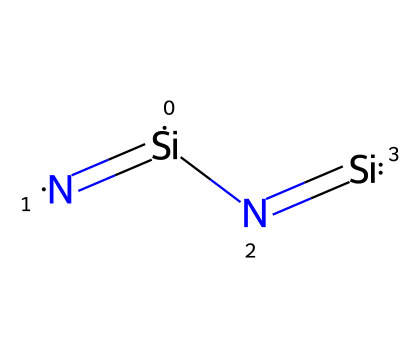What is the primary element in this chemical? The chemical structure predominantly features silicon, indicated by the presence of the Si atoms.
Answer: silicon How many nitrogen atoms are present in this chemical? The SMILES representation shows two nitrogen atoms connected to silicon, indicated by the [N] symbols.
Answer: 2 What type of bonding is primarily present in silicon nitride ceramics? The structure shows covalent bonding between silicon and nitrogen, as indicated by the shared electrons depicted in the double bonds.
Answer: covalent How does silicon nitride's bonding contribute to its hardness? The strong covalent bonds between silicon and nitrogen create a rigid lattice structure, making the material harder and more resistant to wear and deformation.
Answer: hardness What is the significance of the double bonds in silicon nitride? The presence of double bonds between silicon and nitrogen increases the strength of the material by providing greater electron sharing, which enhances its stability and durability.
Answer: stability What type of material is silicon nitride classified as? Based on its properties and structure, silicon nitride is classified as a ceramic material, known for high-strength and thermal resistance in industrial applications.
Answer: ceramic 